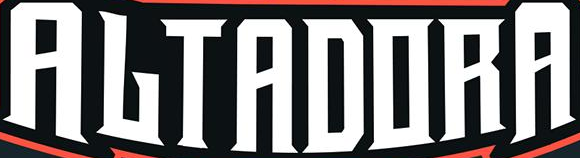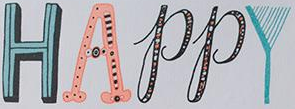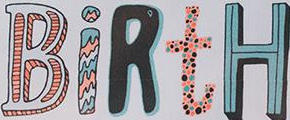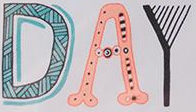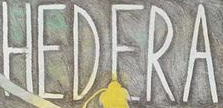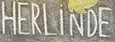Identify the words shown in these images in order, separated by a semicolon. ALTADORA; HAPPY; BiRtH; DAY; HEDERA; HERLiNDE 